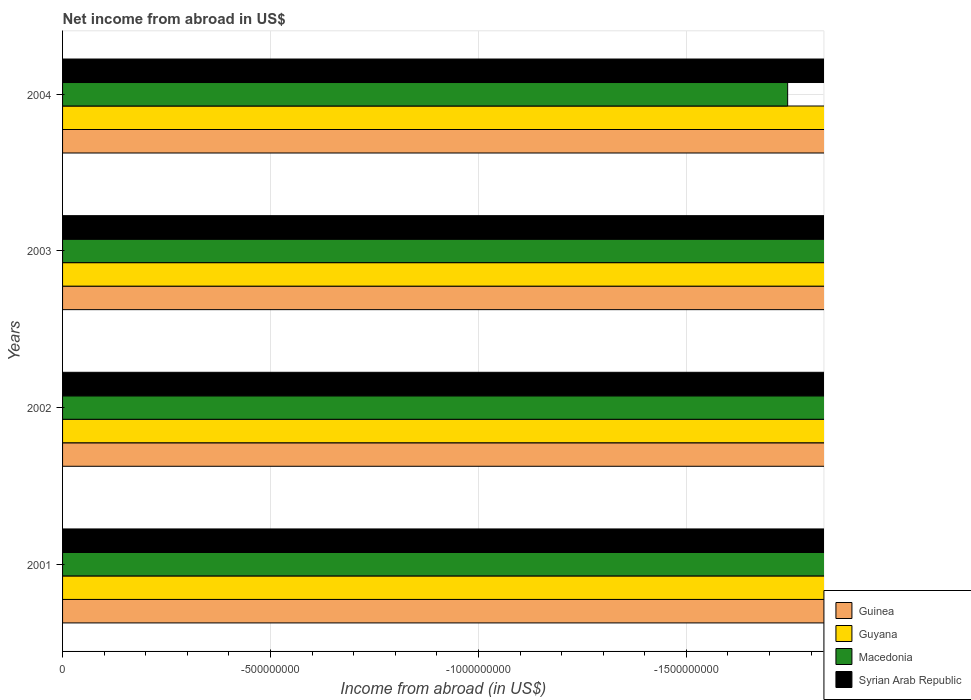Are the number of bars per tick equal to the number of legend labels?
Give a very brief answer. No. How many bars are there on the 4th tick from the top?
Offer a very short reply. 0. What is the label of the 3rd group of bars from the top?
Your answer should be compact. 2002. In how many cases, is the number of bars for a given year not equal to the number of legend labels?
Ensure brevity in your answer.  4. Across all years, what is the minimum net income from abroad in Macedonia?
Keep it short and to the point. 0. What is the average net income from abroad in Macedonia per year?
Your answer should be compact. 0. Is it the case that in every year, the sum of the net income from abroad in Syrian Arab Republic and net income from abroad in Guyana is greater than the sum of net income from abroad in Macedonia and net income from abroad in Guinea?
Keep it short and to the point. No. Is it the case that in every year, the sum of the net income from abroad in Syrian Arab Republic and net income from abroad in Guyana is greater than the net income from abroad in Macedonia?
Provide a succinct answer. No. How many years are there in the graph?
Provide a short and direct response. 4. Are the values on the major ticks of X-axis written in scientific E-notation?
Give a very brief answer. No. Where does the legend appear in the graph?
Your answer should be very brief. Bottom right. How many legend labels are there?
Offer a terse response. 4. How are the legend labels stacked?
Your response must be concise. Vertical. What is the title of the graph?
Your response must be concise. Net income from abroad in US$. What is the label or title of the X-axis?
Keep it short and to the point. Income from abroad (in US$). What is the label or title of the Y-axis?
Your response must be concise. Years. What is the Income from abroad (in US$) in Guinea in 2001?
Offer a very short reply. 0. What is the Income from abroad (in US$) in Guyana in 2001?
Your answer should be very brief. 0. What is the Income from abroad (in US$) in Syrian Arab Republic in 2001?
Your response must be concise. 0. What is the Income from abroad (in US$) of Guinea in 2002?
Make the answer very short. 0. What is the Income from abroad (in US$) in Guyana in 2002?
Provide a short and direct response. 0. What is the Income from abroad (in US$) of Macedonia in 2002?
Your answer should be very brief. 0. What is the Income from abroad (in US$) of Syrian Arab Republic in 2002?
Ensure brevity in your answer.  0. What is the Income from abroad (in US$) in Macedonia in 2003?
Make the answer very short. 0. What is the Income from abroad (in US$) of Syrian Arab Republic in 2003?
Your answer should be very brief. 0. What is the Income from abroad (in US$) of Macedonia in 2004?
Make the answer very short. 0. What is the total Income from abroad (in US$) in Guinea in the graph?
Keep it short and to the point. 0. What is the total Income from abroad (in US$) in Guyana in the graph?
Provide a short and direct response. 0. What is the total Income from abroad (in US$) in Macedonia in the graph?
Provide a short and direct response. 0. What is the total Income from abroad (in US$) in Syrian Arab Republic in the graph?
Keep it short and to the point. 0. What is the average Income from abroad (in US$) of Guinea per year?
Your answer should be very brief. 0. What is the average Income from abroad (in US$) of Macedonia per year?
Make the answer very short. 0. What is the average Income from abroad (in US$) of Syrian Arab Republic per year?
Provide a succinct answer. 0. 